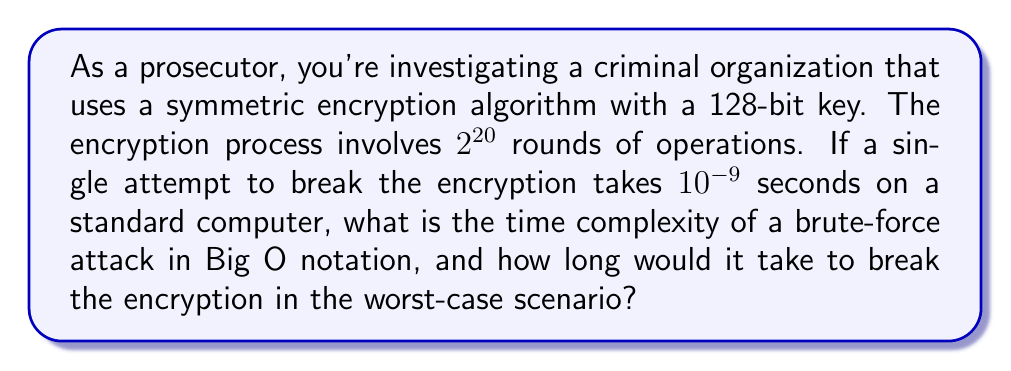Give your solution to this math problem. 1. First, let's consider the key space:
   - For a 128-bit key, there are $2^{128}$ possible keys.

2. Time for a single attempt:
   - Each attempt takes $10^{-9}$ seconds.

3. Worst-case scenario:
   - In the worst case, we need to try all possible keys.
   - Total time = $2^{128} \times 10^{-9}$ seconds

4. Time complexity analysis:
   - The number of operations is proportional to the key space.
   - Therefore, the time complexity is $O(2^n)$, where $n$ is the key size in bits.
   - In this case, it's $O(2^{128})$.

5. Calculate the actual time:
   - Time = $2^{128} \times 10^{-9}$ seconds
   - $= 2^{128} \times 10^{-9} \div (60 \times 60 \times 24 \times 365)$ years
   - $\approx 1.0746 \times 10^{22}$ years

Note: The number of rounds ($2^{20}$) doesn't affect the time complexity of the brute-force attack, as it's constant for each attempt.
Answer: $O(2^{128})$; $\approx 1.0746 \times 10^{22}$ years 